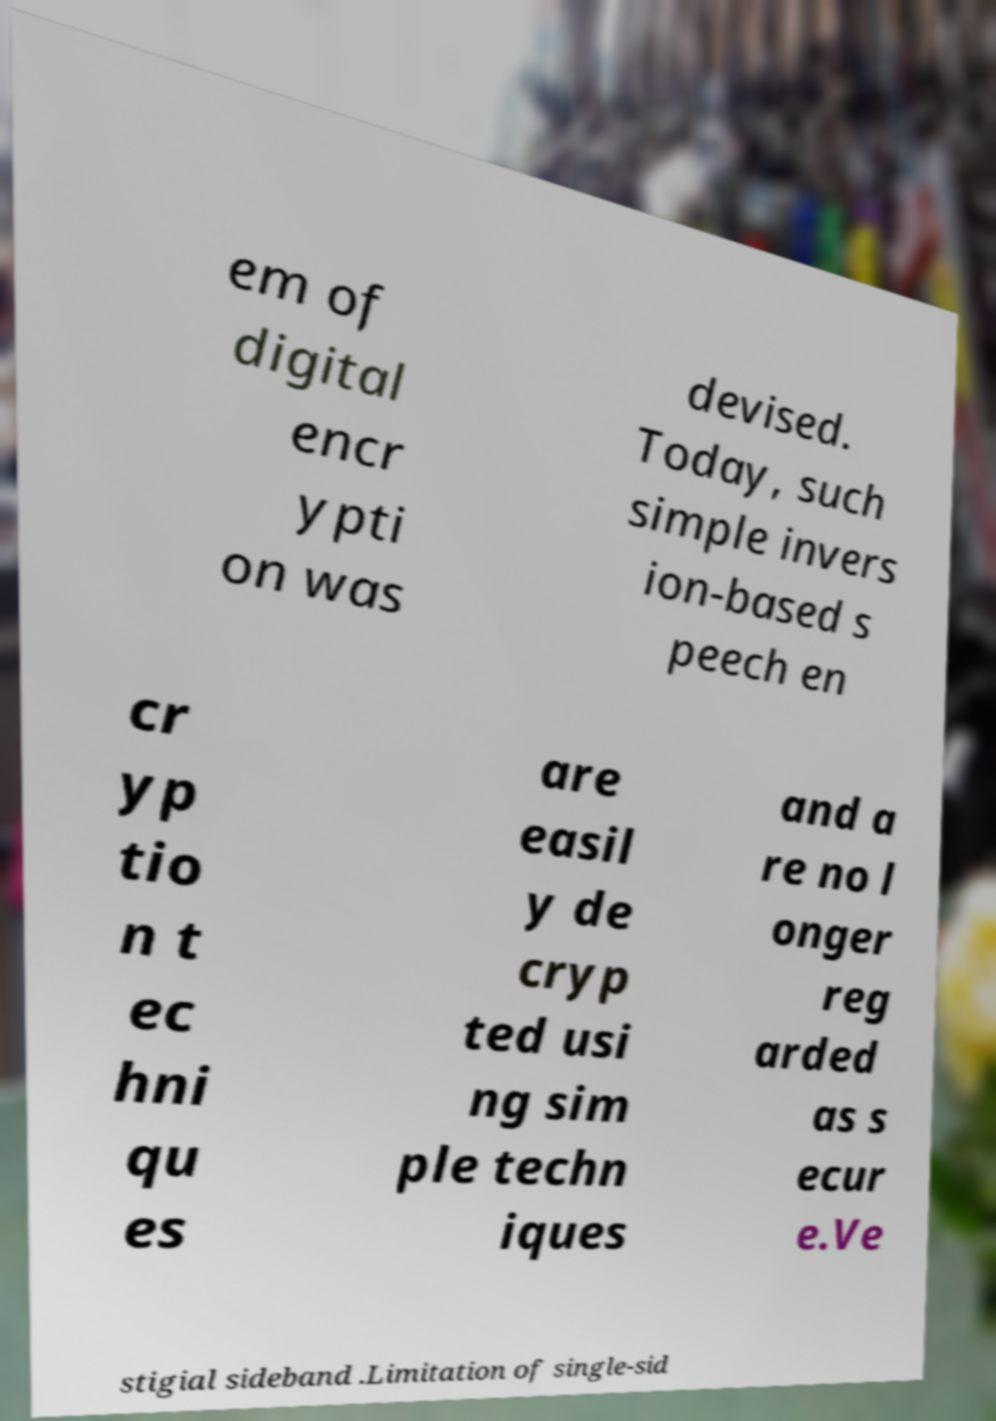For documentation purposes, I need the text within this image transcribed. Could you provide that? em of digital encr ypti on was devised. Today, such simple invers ion-based s peech en cr yp tio n t ec hni qu es are easil y de cryp ted usi ng sim ple techn iques and a re no l onger reg arded as s ecur e.Ve stigial sideband .Limitation of single-sid 